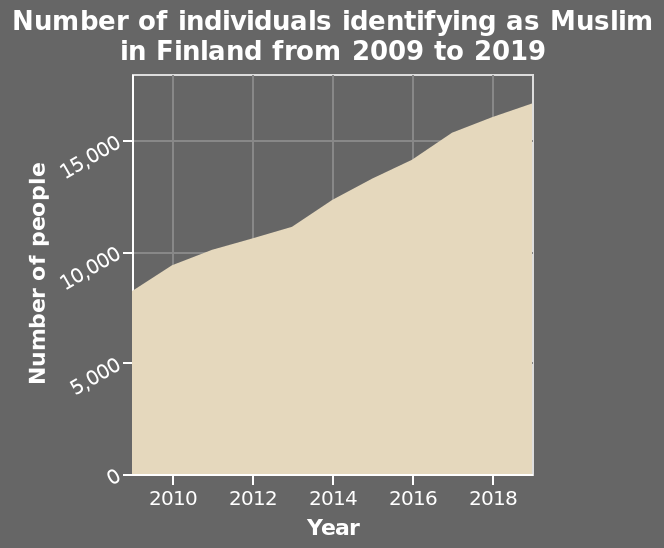<image>
Is the population of Muslims in Finland stable? No, the population of Muslims in Finland is steadily increasing, indicating a growing community. 